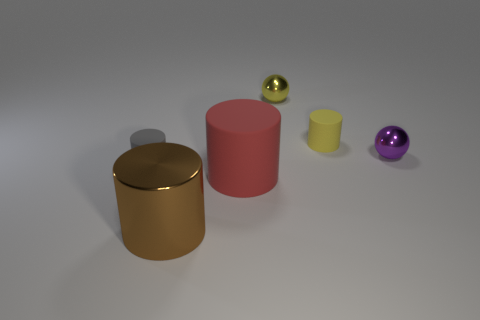What can you infer about the surface on which the objects are placed? The surface appears to be smooth and matte, with subtle reflections indicating it might be made of a material like fine, brushed metal or stone. It's uniformly colored in a neutral tone which provides a good contrast for the objects placed on it. How does the texture of the objects compare to the surface? The objects offer a variety of textures in contrast to the smooth surface. The golden cylinder has a reflective, glossy finish, while the red and yellow cylinders appear to have a matte, slightly rough texture. The spheres have a smooth finish with varying degrees of reflectivity from matte to shiny, enhancing the visual interest of the scene. 